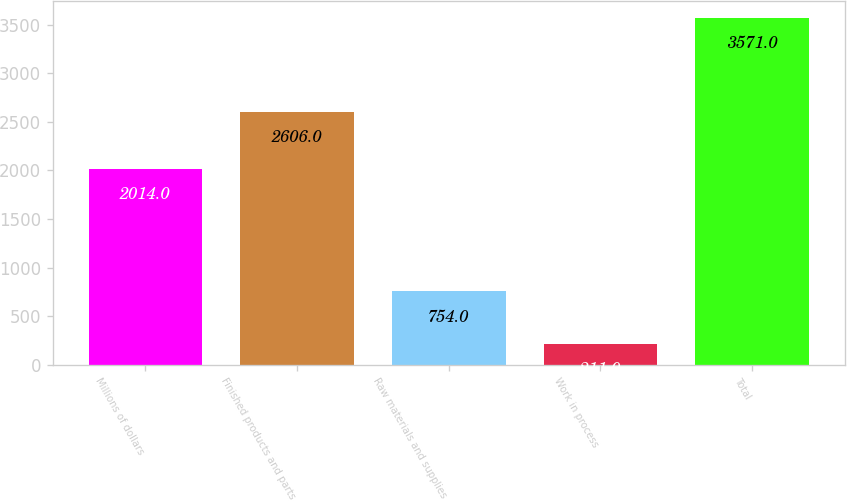Convert chart to OTSL. <chart><loc_0><loc_0><loc_500><loc_500><bar_chart><fcel>Millions of dollars<fcel>Finished products and parts<fcel>Raw materials and supplies<fcel>Work in process<fcel>Total<nl><fcel>2014<fcel>2606<fcel>754<fcel>211<fcel>3571<nl></chart> 